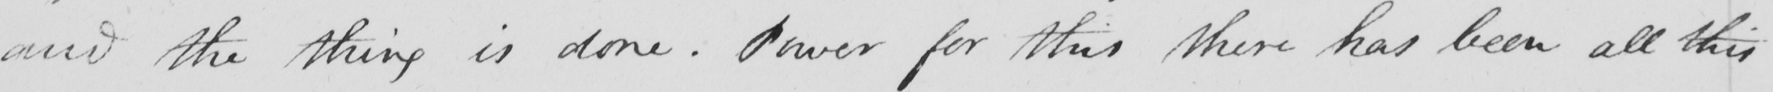Please transcribe the handwritten text in this image. and the thing is done . Power for this there has been all this 